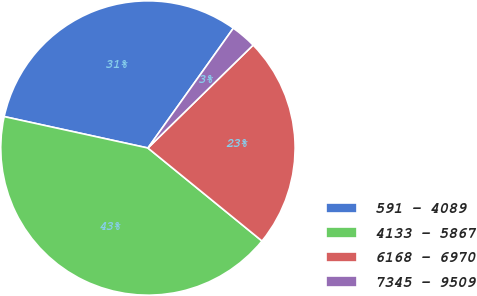Convert chart. <chart><loc_0><loc_0><loc_500><loc_500><pie_chart><fcel>591 - 4089<fcel>4133 - 5867<fcel>6168 - 6970<fcel>7345 - 9509<nl><fcel>31.43%<fcel>42.54%<fcel>23.21%<fcel>2.82%<nl></chart> 